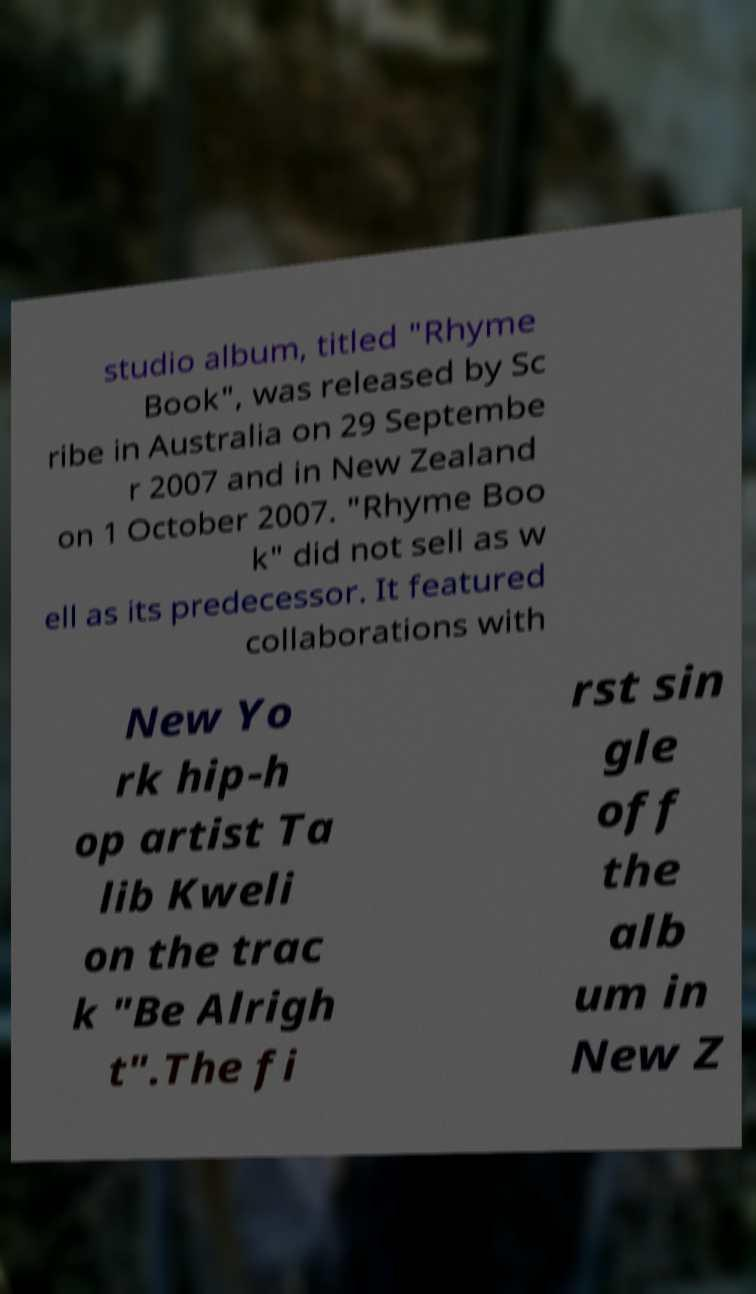What messages or text are displayed in this image? I need them in a readable, typed format. studio album, titled "Rhyme Book", was released by Sc ribe in Australia on 29 Septembe r 2007 and in New Zealand on 1 October 2007. "Rhyme Boo k" did not sell as w ell as its predecessor. It featured collaborations with New Yo rk hip-h op artist Ta lib Kweli on the trac k "Be Alrigh t".The fi rst sin gle off the alb um in New Z 